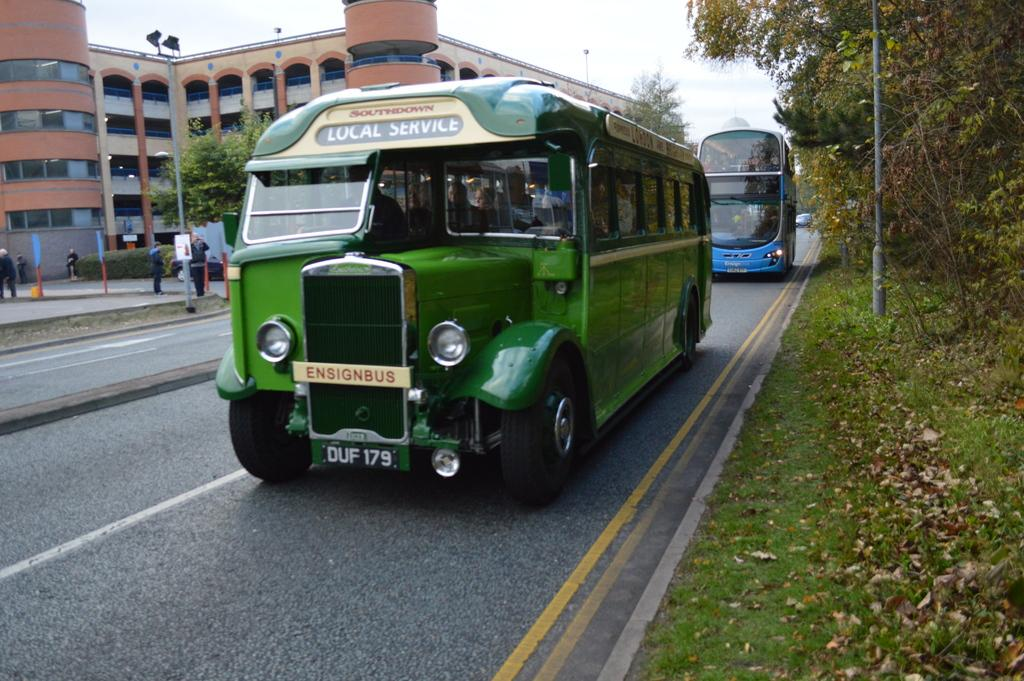What type of vehicles can be seen on the road in the image? There are buses on the road in the image. What are the people in the image doing? The people in the image are standing. What type of lighting is present in the image? Pole lights are visible in the image. What can be seen in the background of the image? There are buildings in the background of the image. What type of vegetation is present in the image? Trees and plants are visible in the image. What is the condition of the sky in the image? The sky is cloudy in the image. What type of silk is draped over the frame in the image? There is no silk or frame present in the image. What color is the glove worn by the person in the image? There are no gloves visible in the image. 